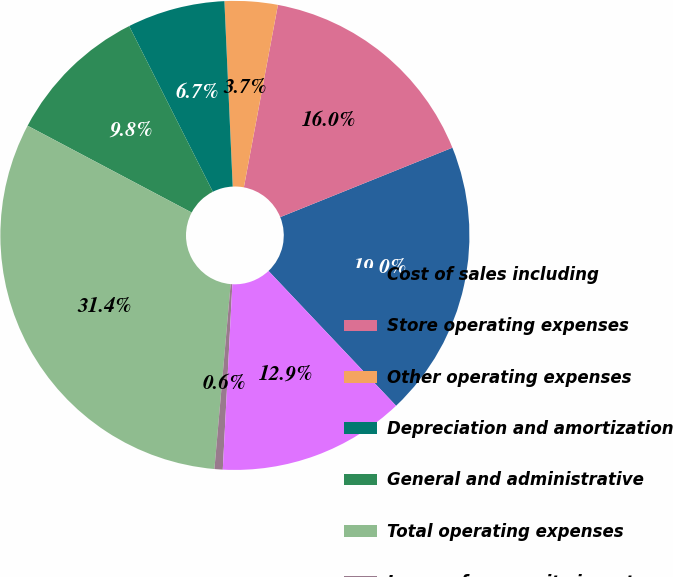<chart> <loc_0><loc_0><loc_500><loc_500><pie_chart><fcel>Cost of sales including<fcel>Store operating expenses<fcel>Other operating expenses<fcel>Depreciation and amortization<fcel>General and administrative<fcel>Total operating expenses<fcel>Income from equity investees<fcel>Operating income<nl><fcel>19.04%<fcel>15.96%<fcel>3.65%<fcel>6.73%<fcel>9.81%<fcel>31.35%<fcel>0.57%<fcel>12.88%<nl></chart> 